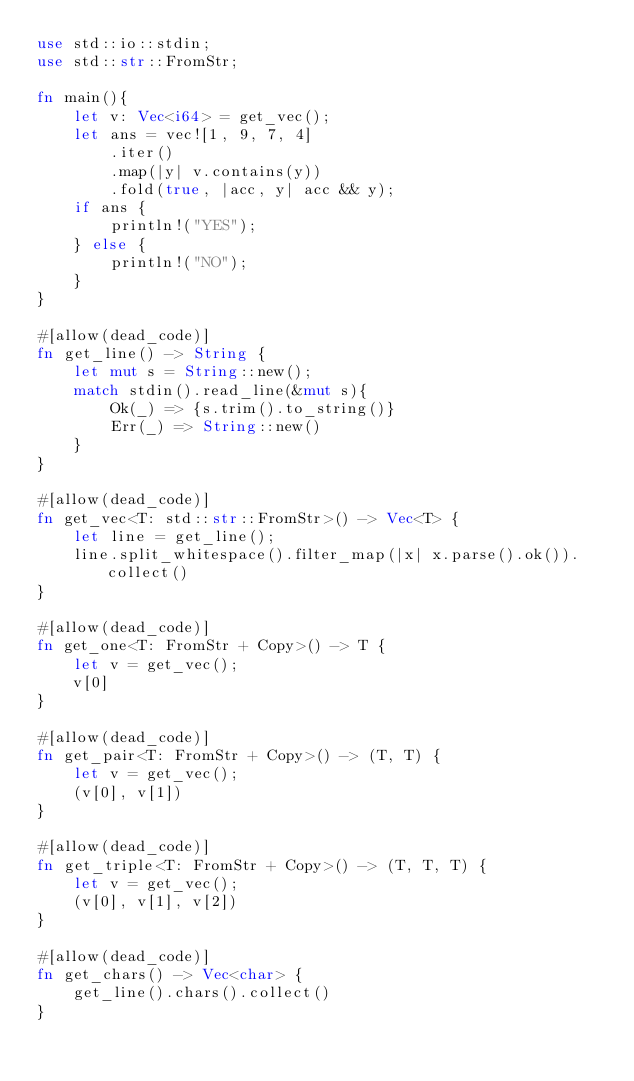<code> <loc_0><loc_0><loc_500><loc_500><_Rust_>use std::io::stdin;
use std::str::FromStr;

fn main(){
    let v: Vec<i64> = get_vec();
    let ans = vec![1, 9, 7, 4]
        .iter()
        .map(|y| v.contains(y))
        .fold(true, |acc, y| acc && y);
    if ans {
        println!("YES");
    } else {
        println!("NO");
    }
}

#[allow(dead_code)]
fn get_line() -> String {
    let mut s = String::new();
    match stdin().read_line(&mut s){
        Ok(_) => {s.trim().to_string()}
        Err(_) => String::new()
    }
}

#[allow(dead_code)]
fn get_vec<T: std::str::FromStr>() -> Vec<T> {
    let line = get_line();
    line.split_whitespace().filter_map(|x| x.parse().ok()).collect()
}

#[allow(dead_code)]
fn get_one<T: FromStr + Copy>() -> T {
    let v = get_vec();
    v[0]
}

#[allow(dead_code)]
fn get_pair<T: FromStr + Copy>() -> (T, T) {
    let v = get_vec();
    (v[0], v[1])
}

#[allow(dead_code)]
fn get_triple<T: FromStr + Copy>() -> (T, T, T) {
    let v = get_vec();
    (v[0], v[1], v[2])
}

#[allow(dead_code)]
fn get_chars() -> Vec<char> {
    get_line().chars().collect()
}
</code> 